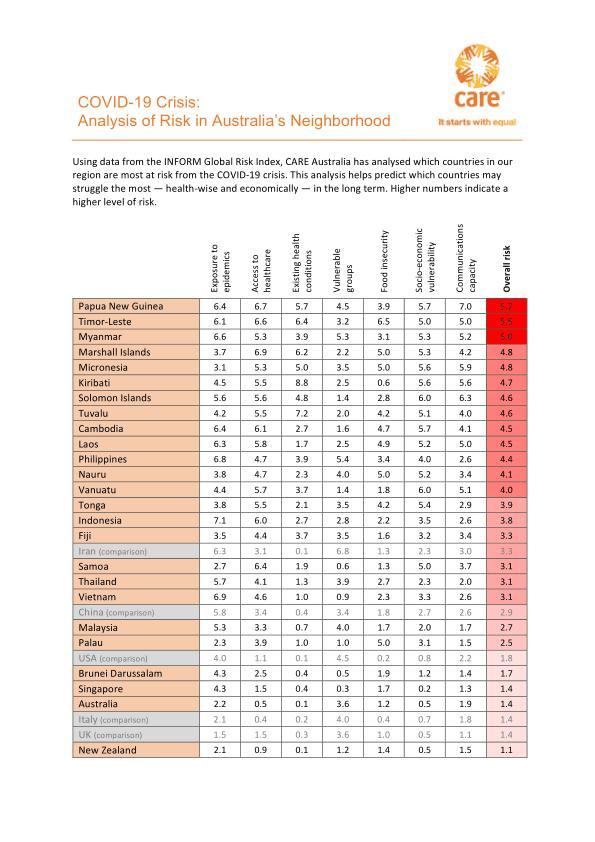Which two countries have a risk index of 4.3 for exposure to epidemics?
Answer the question with a short phrase. Brunei Darussalam, Singapore Which countries have 'access to healthcare' risk index below 1.0? Australia, Italy, New Zealand Which are the two highest risk areas for New Zealand? Exposure to epidemics, communications capacity Which countries have a risk index above 6.0 for communications capacity? Solomon Islands, Papua New Guinea Which countries have an overall risk index between 2.0 and 3.0? China, Malaysia, Palau Which is the area of highest risk for Papua New Guinea? Communications capacity How much is the overall risk index of Marshall Islands more than that of Indonesia? 1.0 By how much, is the risk index for exposure to epidemics in Papua New Guinea higher than that of New Zealand? 4.3 Which three countries are most at risk from the covid-19 crisis? Papua New Guinea, Timor Leste, Myanmar By how much is the risk index for exposure to epidemics of Myanmar, higher than that of Solomon Islands? 1.0 Which country has the highest risk index with regard to vulnerable groups? Iran 